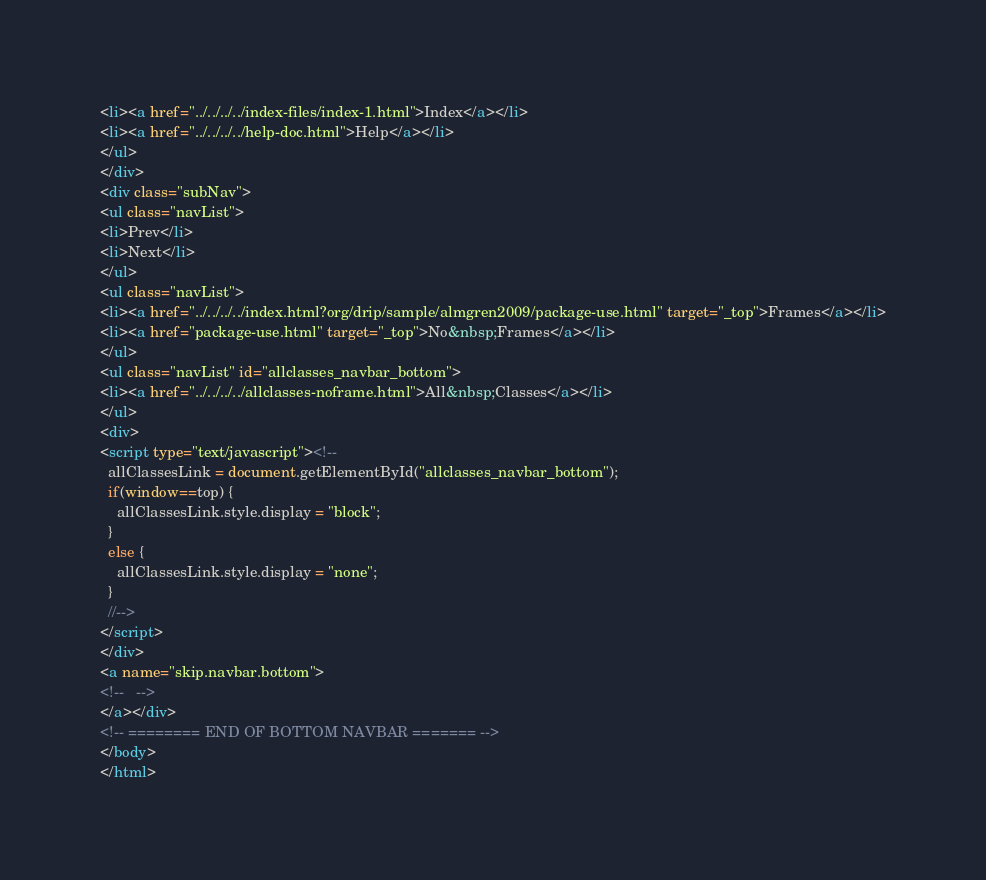<code> <loc_0><loc_0><loc_500><loc_500><_HTML_><li><a href="../../../../index-files/index-1.html">Index</a></li>
<li><a href="../../../../help-doc.html">Help</a></li>
</ul>
</div>
<div class="subNav">
<ul class="navList">
<li>Prev</li>
<li>Next</li>
</ul>
<ul class="navList">
<li><a href="../../../../index.html?org/drip/sample/almgren2009/package-use.html" target="_top">Frames</a></li>
<li><a href="package-use.html" target="_top">No&nbsp;Frames</a></li>
</ul>
<ul class="navList" id="allclasses_navbar_bottom">
<li><a href="../../../../allclasses-noframe.html">All&nbsp;Classes</a></li>
</ul>
<div>
<script type="text/javascript"><!--
  allClassesLink = document.getElementById("allclasses_navbar_bottom");
  if(window==top) {
    allClassesLink.style.display = "block";
  }
  else {
    allClassesLink.style.display = "none";
  }
  //-->
</script>
</div>
<a name="skip.navbar.bottom">
<!--   -->
</a></div>
<!-- ======== END OF BOTTOM NAVBAR ======= -->
</body>
</html>
</code> 